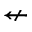Convert formula to latex. <formula><loc_0><loc_0><loc_500><loc_500>\ n l e f t a r r o w</formula> 